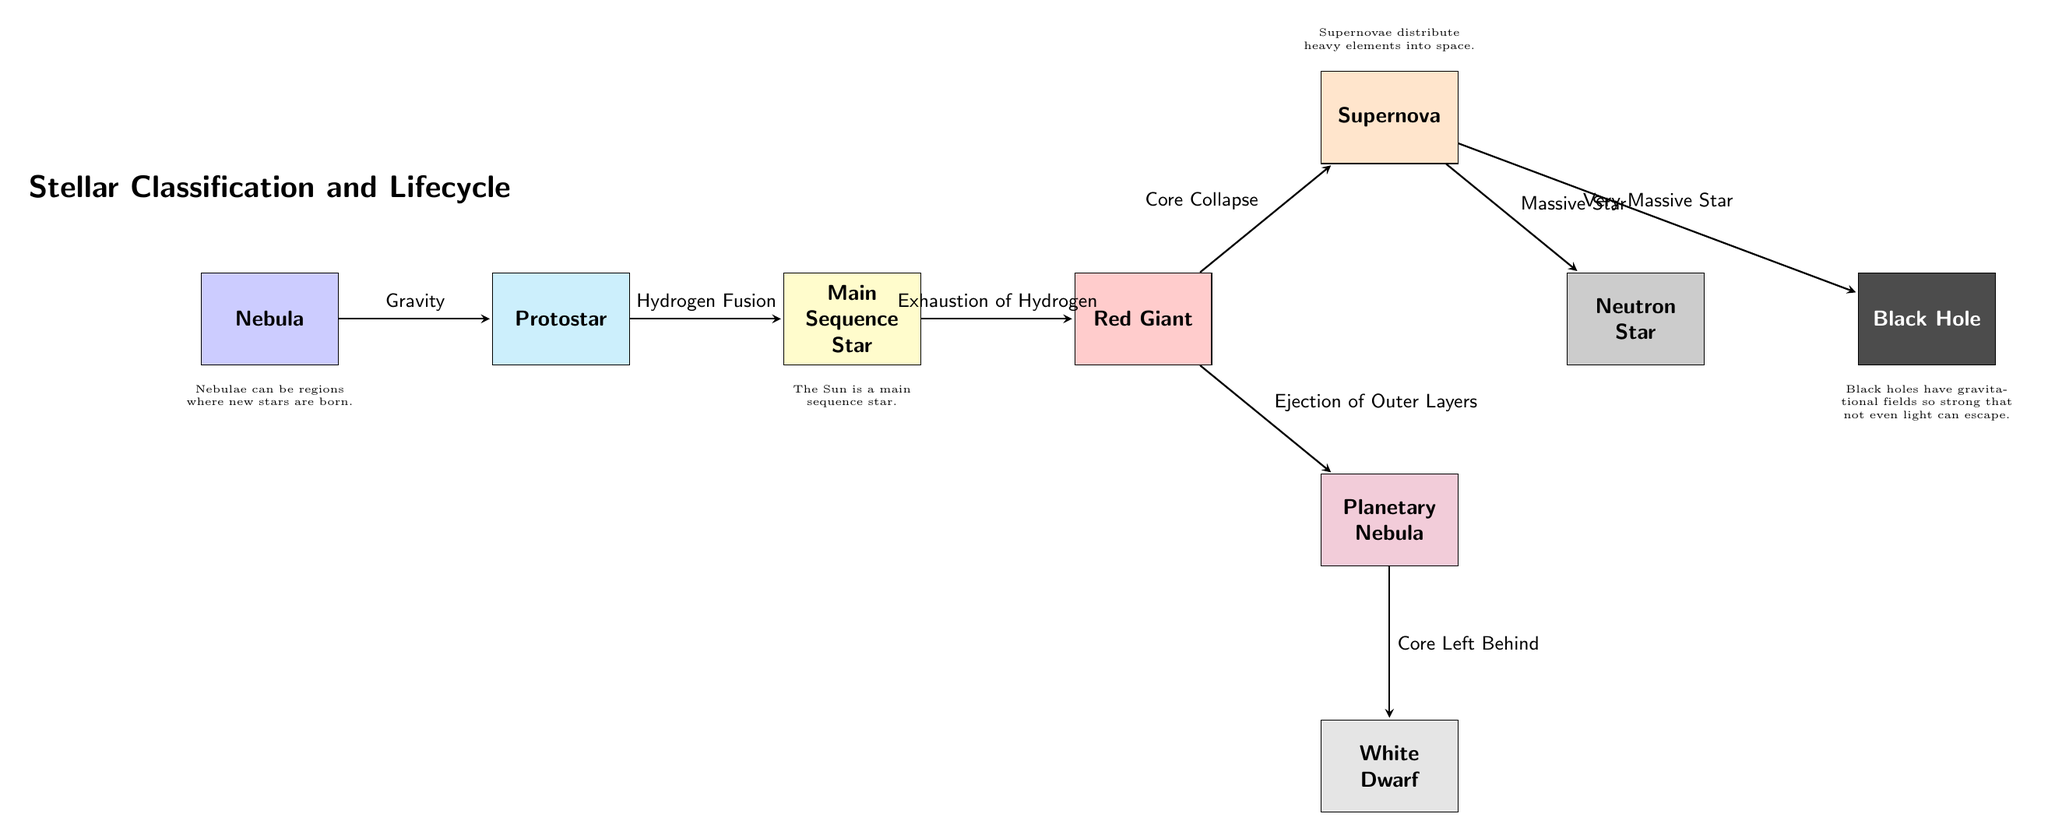What is the first stage of stellar evolution shown in the diagram? The diagram begins with the node labeled "Nebula," which is the initial stage of stellar evolution where stars are born.
Answer: Nebula How many main nodes are present in the flowchart? The flowchart includes a sequence of main nodes, specifically: Nebula, Protostar, Main Sequence Star, Red Giant, Planetary Nebula, White Dwarf, Supernova, Neutron Star, and Black Hole. Counting these, there are a total of nine main nodes.
Answer: 9 What process transforms a protostar into a main sequence star? According to the diagram, the transition from Protostar to Main Sequence Star is driven by the process called "Hydrogen Fusion."
Answer: Hydrogen Fusion What transition occurs from the Red Giant to the Planetary Nebula? The diagram indicates that the transition from Red Giant to Planetary Nebula happens through the "Ejection of Outer Layers," which signifies the outer parts of the star being expelled.
Answer: Ejection of Outer Layers Which stage follows a Supernova for a very massive star? The flowchart shows that for very massive stars, following the Supernova, the evolution leads to the formation of a Black Hole. This is indicated by the directional arrow labeled "Very Massive Star."
Answer: Black Hole What is a characteristic of White Dwarfs as suggested in the diagram? The diagram provides a note under the White Dwarf node stating that it is the result of the core left behind after a Planetary Nebula, emphasizing its formation process.
Answer: Core Left Behind Which process leads to the creation of a Neutron Star? The diagram shows that after a Supernova, a "Massive Star" leads to the formation of a Neutron Star, indicating a specific evolutionary route for stars with sufficient mass.
Answer: Massive Star 